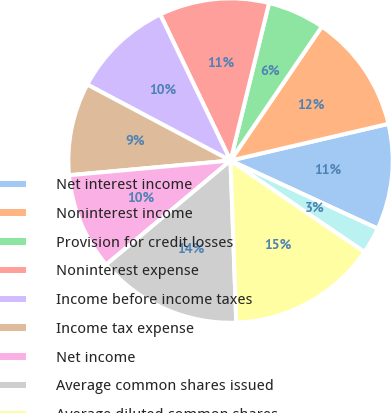<chart> <loc_0><loc_0><loc_500><loc_500><pie_chart><fcel>Net interest income<fcel>Noninterest income<fcel>Provision for credit losses<fcel>Noninterest expense<fcel>Income before income taxes<fcel>Income tax expense<fcel>Net income<fcel>Average common shares issued<fcel>Average diluted common shares<fcel>Return on average assets<nl><fcel>10.53%<fcel>11.84%<fcel>5.7%<fcel>10.96%<fcel>10.09%<fcel>9.21%<fcel>9.65%<fcel>14.47%<fcel>14.91%<fcel>2.63%<nl></chart> 